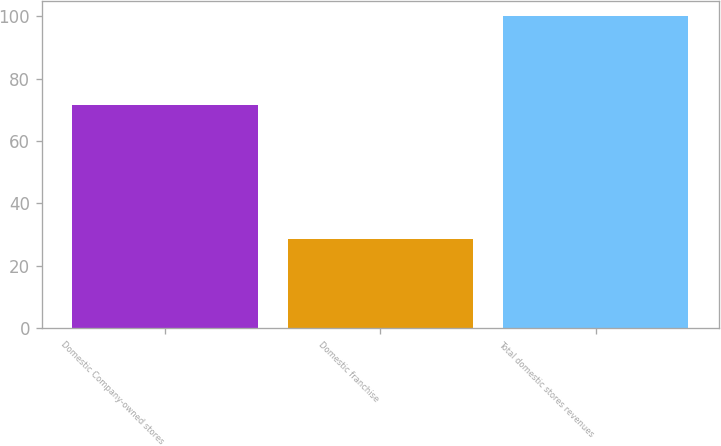Convert chart to OTSL. <chart><loc_0><loc_0><loc_500><loc_500><bar_chart><fcel>Domestic Company-owned stores<fcel>Domestic franchise<fcel>Total domestic stores revenues<nl><fcel>71.4<fcel>28.6<fcel>100<nl></chart> 